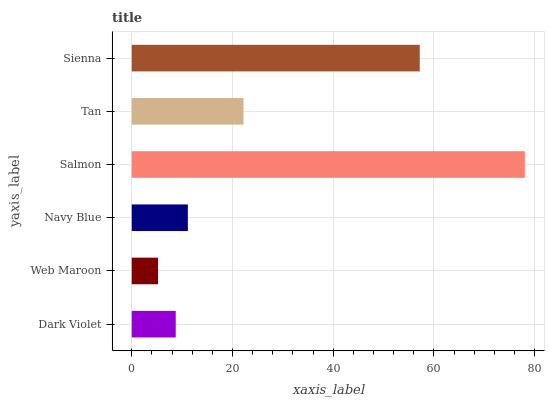Is Web Maroon the minimum?
Answer yes or no. Yes. Is Salmon the maximum?
Answer yes or no. Yes. Is Navy Blue the minimum?
Answer yes or no. No. Is Navy Blue the maximum?
Answer yes or no. No. Is Navy Blue greater than Web Maroon?
Answer yes or no. Yes. Is Web Maroon less than Navy Blue?
Answer yes or no. Yes. Is Web Maroon greater than Navy Blue?
Answer yes or no. No. Is Navy Blue less than Web Maroon?
Answer yes or no. No. Is Tan the high median?
Answer yes or no. Yes. Is Navy Blue the low median?
Answer yes or no. Yes. Is Dark Violet the high median?
Answer yes or no. No. Is Dark Violet the low median?
Answer yes or no. No. 